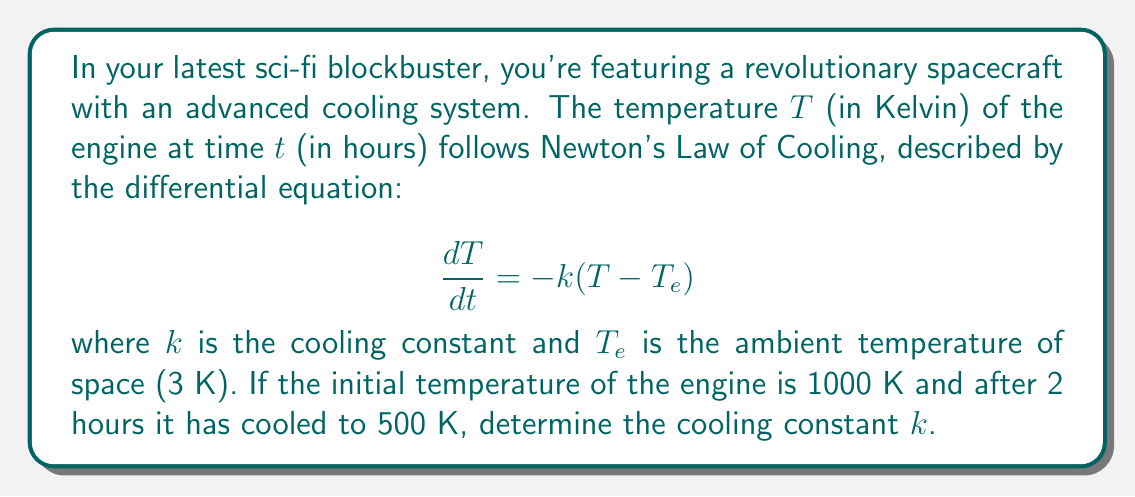Solve this math problem. To solve this problem, we'll follow these steps:

1) First, let's recall the general solution to Newton's Law of Cooling:

   $$T(t) = T_e + (T_0 - T_e)e^{-kt}$$

   where $T_0$ is the initial temperature.

2) We're given the following information:
   $T_e = 3$ K
   $T_0 = 1000$ K
   At $t = 2$ hours, $T = 500$ K

3) Let's substitute these values into our general solution:

   $$500 = 3 + (1000 - 3)e^{-2k}$$

4) Simplify:

   $$497 = 997e^{-2k}$$

5) Divide both sides by 997:

   $$\frac{497}{997} = e^{-2k}$$

6) Take the natural logarithm of both sides:

   $$\ln(\frac{497}{997}) = -2k$$

7) Solve for $k$:

   $$k = -\frac{1}{2}\ln(\frac{497}{997})$$

8) Calculate the value:

   $$k \approx 0.3466$$

Thus, the cooling constant $k$ is approximately 0.3466 hour^(-1).
Answer: $k \approx 0.3466$ hour^(-1) 